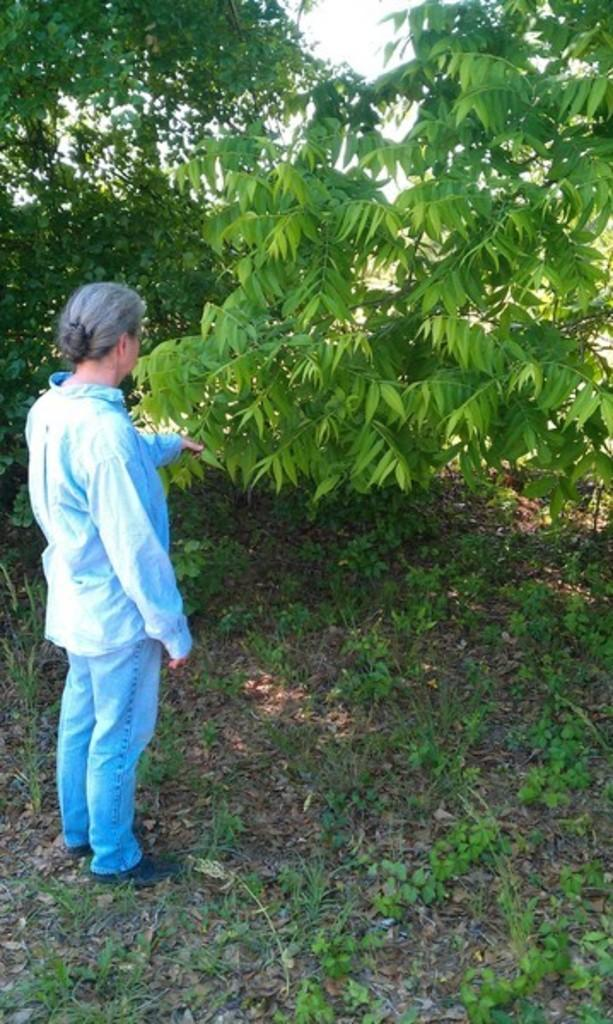Who is present in the image? There is a lady in the image. Where is the lady positioned in the image? The lady is standing on the left side. What can be seen on the ground in the image? There are plants on the ground. What type of vegetation is visible in the image? There are trees in the image. What is the lady holding in the image? The lady is holding a stem of a tree. What type of train can be seen in the image? There is no train present in the image. What ornament is hanging from the tree in the image? There is no ornament mentioned in the image; the lady is holding a stem of a tree. 